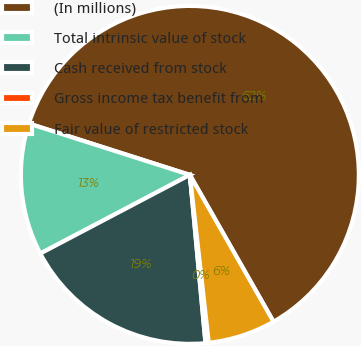Convert chart to OTSL. <chart><loc_0><loc_0><loc_500><loc_500><pie_chart><fcel>(In millions)<fcel>Total intrinsic value of stock<fcel>Cash received from stock<fcel>Gross income tax benefit from<fcel>Fair value of restricted stock<nl><fcel>61.85%<fcel>12.62%<fcel>18.77%<fcel>0.31%<fcel>6.46%<nl></chart> 